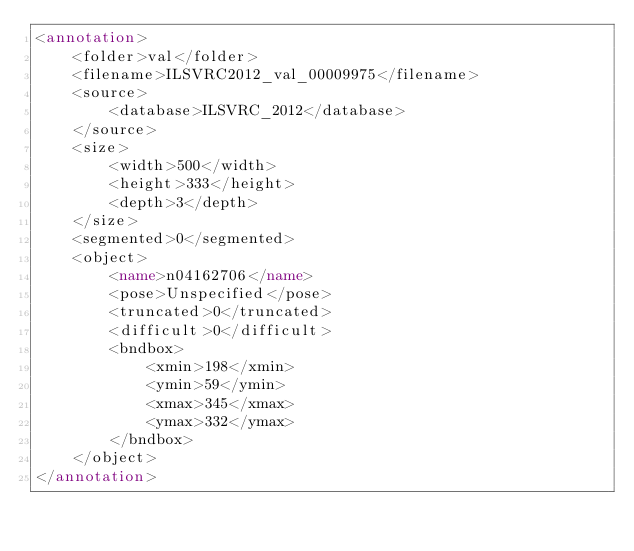Convert code to text. <code><loc_0><loc_0><loc_500><loc_500><_XML_><annotation>
	<folder>val</folder>
	<filename>ILSVRC2012_val_00009975</filename>
	<source>
		<database>ILSVRC_2012</database>
	</source>
	<size>
		<width>500</width>
		<height>333</height>
		<depth>3</depth>
	</size>
	<segmented>0</segmented>
	<object>
		<name>n04162706</name>
		<pose>Unspecified</pose>
		<truncated>0</truncated>
		<difficult>0</difficult>
		<bndbox>
			<xmin>198</xmin>
			<ymin>59</ymin>
			<xmax>345</xmax>
			<ymax>332</ymax>
		</bndbox>
	</object>
</annotation></code> 